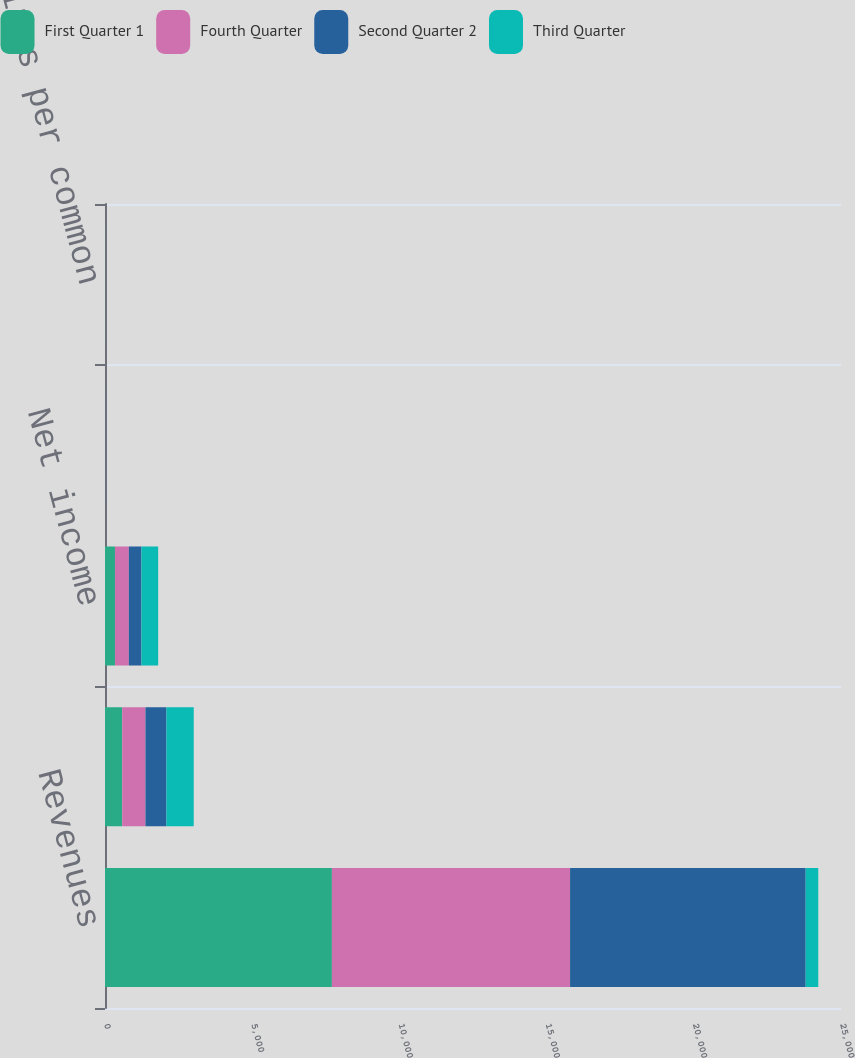Convert chart to OTSL. <chart><loc_0><loc_0><loc_500><loc_500><stacked_bar_chart><ecel><fcel>Revenues<fcel>Operating income<fcel>Net income<fcel>Basic earnings per common<fcel>Diluted earnings per common<nl><fcel>First Quarter 1<fcel>7707<fcel>584<fcel>339<fcel>1.12<fcel>1.1<nl><fcel>Fourth Quarter<fcel>8090<fcel>790<fcel>471<fcel>1.55<fcel>1.53<nl><fcel>Second Quarter 2<fcel>8003<fcel>713<fcel>428<fcel>1.41<fcel>1.38<nl><fcel>Third Quarter<fcel>428<fcel>927<fcel>568<fcel>1.86<fcel>1.82<nl></chart> 